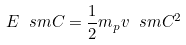<formula> <loc_0><loc_0><loc_500><loc_500>E _ { \ } s m C = \frac { 1 } { 2 } m _ { p } v _ { \ } s m C ^ { 2 }</formula> 